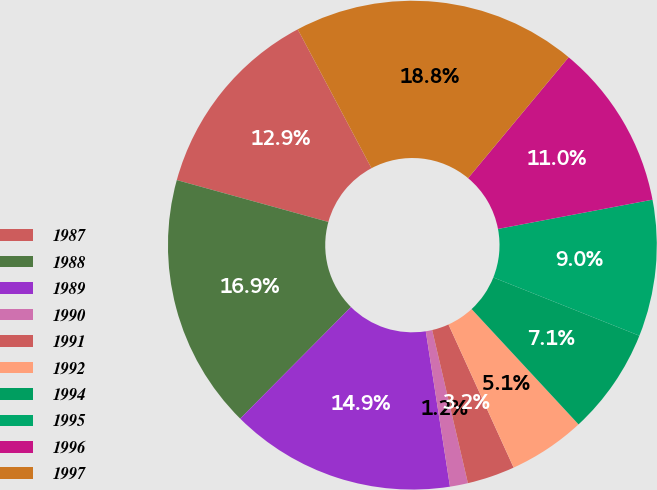Convert chart to OTSL. <chart><loc_0><loc_0><loc_500><loc_500><pie_chart><fcel>1987<fcel>1988<fcel>1989<fcel>1990<fcel>1991<fcel>1992<fcel>1994<fcel>1995<fcel>1996<fcel>1997<nl><fcel>12.94%<fcel>16.85%<fcel>14.9%<fcel>1.19%<fcel>3.15%<fcel>5.1%<fcel>7.06%<fcel>9.02%<fcel>10.98%<fcel>18.81%<nl></chart> 